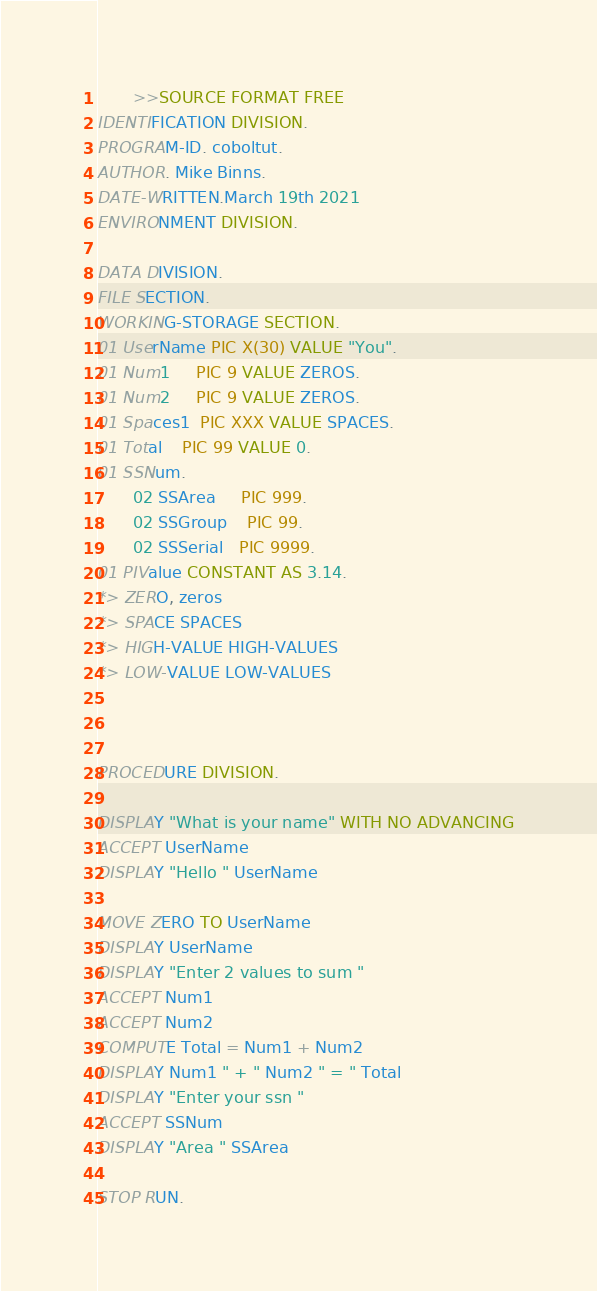Convert code to text. <code><loc_0><loc_0><loc_500><loc_500><_COBOL_>       >>SOURCE FORMAT FREE
IDENTIFICATION DIVISION.
PROGRAM-ID. coboltut.
AUTHOR. Mike Binns.
DATE-WRITTEN.March 19th 2021
ENVIRONMENT DIVISION.

DATA DIVISION.
FILE SECTION.
WORKING-STORAGE SECTION.
01 UserName PIC X(30) VALUE "You".
01 Num1     PIC 9 VALUE ZEROS.
01 Num2     PIC 9 VALUE ZEROS.
01 Spaces1  PIC XXX VALUE SPACES.
01 Total    PIC 99 VALUE 0.
01 SSNum.
       02 SSArea     PIC 999.
       02 SSGroup    PIC 99.
       02 SSSerial   PIC 9999.
01 PIValue CONSTANT AS 3.14.
*> ZERO, zeros
*> SPACE SPACES
*> HIGH-VALUE HIGH-VALUES
*> LOW-VALUE LOW-VALUES



PROCEDURE DIVISION.

DISPLAY "What is your name" WITH NO ADVANCING
ACCEPT UserName
DISPLAY "Hello " UserName

MOVE ZERO TO UserName
DISPLAY UserName
DISPLAY "Enter 2 values to sum "
ACCEPT Num1
ACCEPT Num2
COMPUTE Total = Num1 + Num2
DISPLAY Num1 " + " Num2 " = " Total
DISPLAY "Enter your ssn "
ACCEPT SSNum
DISPLAY "Area " SSArea

STOP RUN.
</code> 